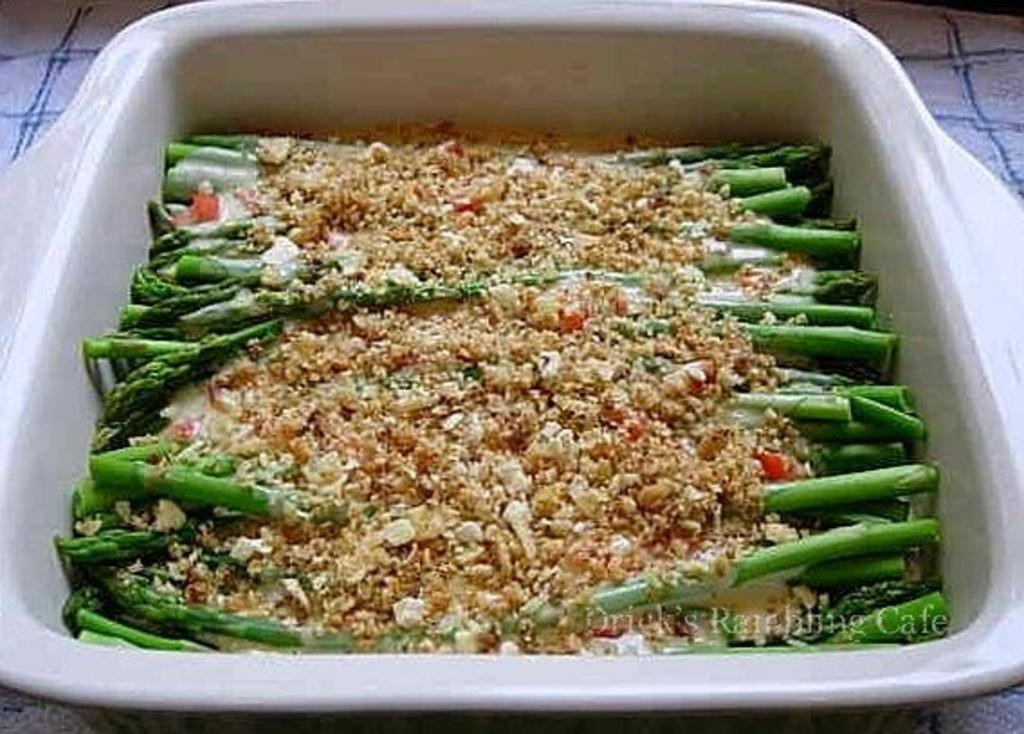What is present in the tray in the image? There is food in the tray. What can be seen behind the tray in the image? There is a background surface visible. Is there any additional information or marking in the image? Yes, there is a watermark in the bottom right of the image. What time is indicated by the clocks in the image? There are no clocks present in the image. What is the condition of the roof in the image? There is no roof visible in the image. 